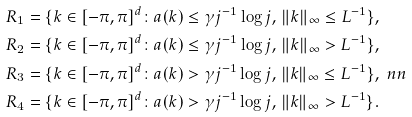<formula> <loc_0><loc_0><loc_500><loc_500>R _ { 1 } & = \{ k \in [ - \pi , \pi ] ^ { d } \colon a ( k ) \leq \gamma j ^ { - 1 } \log j , \, \| k \| _ { \infty } \leq L ^ { - 1 } \} , \\ R _ { 2 } & = \{ k \in [ - \pi , \pi ] ^ { d } \colon a ( k ) \leq \gamma j ^ { - 1 } \log j , \, \| k \| _ { \infty } > L ^ { - 1 } \} , \\ R _ { 3 } & = \{ k \in [ - \pi , \pi ] ^ { d } \colon a ( k ) > \gamma j ^ { - 1 } \log j , \, \| k \| _ { \infty } \leq L ^ { - 1 } \} , \ n n \\ R _ { 4 } & = \{ k \in [ - \pi , \pi ] ^ { d } \colon a ( k ) > \gamma j ^ { - 1 } \log j , \, \| k \| _ { \infty } > L ^ { - 1 } \} .</formula> 